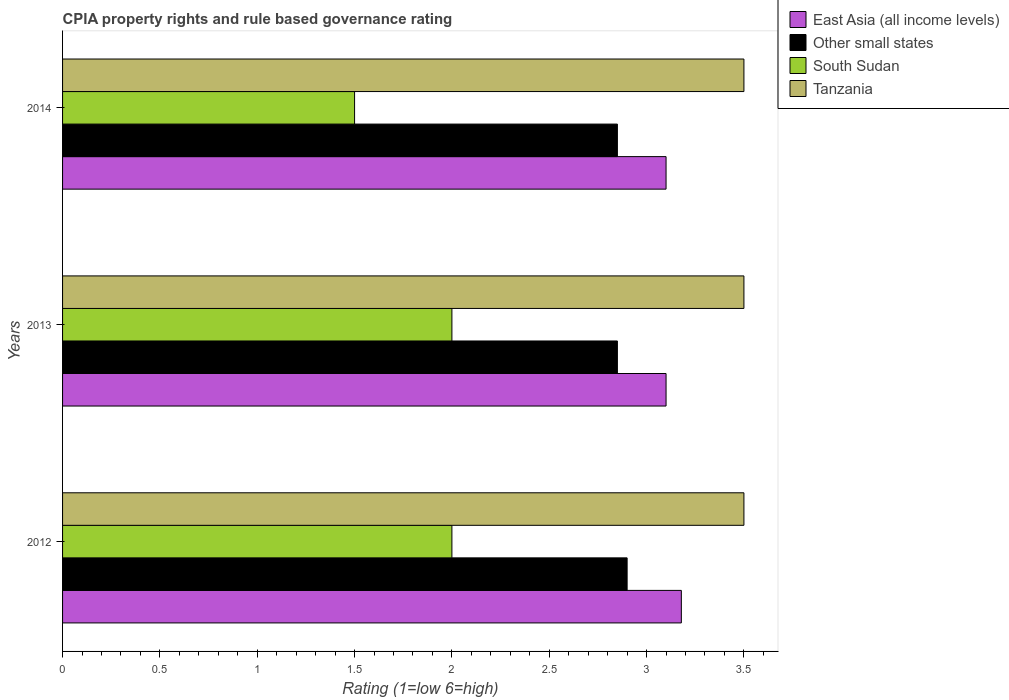How many different coloured bars are there?
Your answer should be compact. 4. In how many cases, is the number of bars for a given year not equal to the number of legend labels?
Your answer should be very brief. 0. What is the CPIA rating in East Asia (all income levels) in 2012?
Provide a short and direct response. 3.18. Across all years, what is the maximum CPIA rating in East Asia (all income levels)?
Provide a short and direct response. 3.18. Across all years, what is the minimum CPIA rating in Tanzania?
Make the answer very short. 3.5. In which year was the CPIA rating in Tanzania maximum?
Give a very brief answer. 2012. What is the total CPIA rating in Other small states in the graph?
Keep it short and to the point. 8.6. What is the difference between the CPIA rating in Other small states in 2012 and that in 2014?
Provide a succinct answer. 0.05. What is the difference between the CPIA rating in Other small states in 2014 and the CPIA rating in South Sudan in 2012?
Provide a short and direct response. 0.85. What is the average CPIA rating in Other small states per year?
Give a very brief answer. 2.87. In the year 2012, what is the difference between the CPIA rating in Other small states and CPIA rating in South Sudan?
Ensure brevity in your answer.  0.9. Is the difference between the CPIA rating in Other small states in 2013 and 2014 greater than the difference between the CPIA rating in South Sudan in 2013 and 2014?
Your answer should be compact. No. What is the difference between the highest and the second highest CPIA rating in East Asia (all income levels)?
Give a very brief answer. 0.08. In how many years, is the CPIA rating in East Asia (all income levels) greater than the average CPIA rating in East Asia (all income levels) taken over all years?
Offer a terse response. 1. Is the sum of the CPIA rating in South Sudan in 2013 and 2014 greater than the maximum CPIA rating in East Asia (all income levels) across all years?
Offer a very short reply. Yes. Is it the case that in every year, the sum of the CPIA rating in East Asia (all income levels) and CPIA rating in Other small states is greater than the sum of CPIA rating in Tanzania and CPIA rating in South Sudan?
Offer a very short reply. Yes. What does the 3rd bar from the top in 2012 represents?
Keep it short and to the point. Other small states. What does the 1st bar from the bottom in 2013 represents?
Ensure brevity in your answer.  East Asia (all income levels). Is it the case that in every year, the sum of the CPIA rating in East Asia (all income levels) and CPIA rating in Other small states is greater than the CPIA rating in Tanzania?
Ensure brevity in your answer.  Yes. How many bars are there?
Keep it short and to the point. 12. Does the graph contain grids?
Your answer should be very brief. No. How many legend labels are there?
Provide a succinct answer. 4. How are the legend labels stacked?
Provide a succinct answer. Vertical. What is the title of the graph?
Your answer should be compact. CPIA property rights and rule based governance rating. Does "Tonga" appear as one of the legend labels in the graph?
Provide a short and direct response. No. What is the label or title of the X-axis?
Give a very brief answer. Rating (1=low 6=high). What is the label or title of the Y-axis?
Offer a very short reply. Years. What is the Rating (1=low 6=high) in East Asia (all income levels) in 2012?
Your answer should be very brief. 3.18. What is the Rating (1=low 6=high) in South Sudan in 2012?
Your response must be concise. 2. What is the Rating (1=low 6=high) of Tanzania in 2012?
Offer a very short reply. 3.5. What is the Rating (1=low 6=high) in East Asia (all income levels) in 2013?
Your answer should be very brief. 3.1. What is the Rating (1=low 6=high) of Other small states in 2013?
Your answer should be compact. 2.85. What is the Rating (1=low 6=high) in Other small states in 2014?
Your response must be concise. 2.85. What is the Rating (1=low 6=high) of South Sudan in 2014?
Your answer should be very brief. 1.5. What is the Rating (1=low 6=high) of Tanzania in 2014?
Ensure brevity in your answer.  3.5. Across all years, what is the maximum Rating (1=low 6=high) of East Asia (all income levels)?
Provide a short and direct response. 3.18. Across all years, what is the maximum Rating (1=low 6=high) in Other small states?
Offer a very short reply. 2.9. Across all years, what is the minimum Rating (1=low 6=high) in East Asia (all income levels)?
Provide a succinct answer. 3.1. Across all years, what is the minimum Rating (1=low 6=high) of Other small states?
Your answer should be very brief. 2.85. What is the total Rating (1=low 6=high) of East Asia (all income levels) in the graph?
Your answer should be compact. 9.38. What is the total Rating (1=low 6=high) of Other small states in the graph?
Offer a very short reply. 8.6. What is the total Rating (1=low 6=high) in South Sudan in the graph?
Ensure brevity in your answer.  5.5. What is the difference between the Rating (1=low 6=high) in East Asia (all income levels) in 2012 and that in 2013?
Make the answer very short. 0.08. What is the difference between the Rating (1=low 6=high) in South Sudan in 2012 and that in 2013?
Offer a terse response. 0. What is the difference between the Rating (1=low 6=high) of East Asia (all income levels) in 2012 and that in 2014?
Keep it short and to the point. 0.08. What is the difference between the Rating (1=low 6=high) in Other small states in 2012 and that in 2014?
Give a very brief answer. 0.05. What is the difference between the Rating (1=low 6=high) of Tanzania in 2012 and that in 2014?
Keep it short and to the point. 0. What is the difference between the Rating (1=low 6=high) of South Sudan in 2013 and that in 2014?
Provide a succinct answer. 0.5. What is the difference between the Rating (1=low 6=high) in Tanzania in 2013 and that in 2014?
Offer a terse response. 0. What is the difference between the Rating (1=low 6=high) of East Asia (all income levels) in 2012 and the Rating (1=low 6=high) of Other small states in 2013?
Give a very brief answer. 0.33. What is the difference between the Rating (1=low 6=high) in East Asia (all income levels) in 2012 and the Rating (1=low 6=high) in South Sudan in 2013?
Your answer should be very brief. 1.18. What is the difference between the Rating (1=low 6=high) of East Asia (all income levels) in 2012 and the Rating (1=low 6=high) of Tanzania in 2013?
Give a very brief answer. -0.32. What is the difference between the Rating (1=low 6=high) in Other small states in 2012 and the Rating (1=low 6=high) in South Sudan in 2013?
Your response must be concise. 0.9. What is the difference between the Rating (1=low 6=high) of Other small states in 2012 and the Rating (1=low 6=high) of Tanzania in 2013?
Ensure brevity in your answer.  -0.6. What is the difference between the Rating (1=low 6=high) of East Asia (all income levels) in 2012 and the Rating (1=low 6=high) of Other small states in 2014?
Provide a succinct answer. 0.33. What is the difference between the Rating (1=low 6=high) in East Asia (all income levels) in 2012 and the Rating (1=low 6=high) in South Sudan in 2014?
Make the answer very short. 1.68. What is the difference between the Rating (1=low 6=high) in East Asia (all income levels) in 2012 and the Rating (1=low 6=high) in Tanzania in 2014?
Your response must be concise. -0.32. What is the difference between the Rating (1=low 6=high) in South Sudan in 2012 and the Rating (1=low 6=high) in Tanzania in 2014?
Provide a short and direct response. -1.5. What is the difference between the Rating (1=low 6=high) in Other small states in 2013 and the Rating (1=low 6=high) in South Sudan in 2014?
Your answer should be compact. 1.35. What is the difference between the Rating (1=low 6=high) of Other small states in 2013 and the Rating (1=low 6=high) of Tanzania in 2014?
Your answer should be compact. -0.65. What is the average Rating (1=low 6=high) of East Asia (all income levels) per year?
Offer a terse response. 3.13. What is the average Rating (1=low 6=high) of Other small states per year?
Provide a succinct answer. 2.87. What is the average Rating (1=low 6=high) of South Sudan per year?
Your answer should be compact. 1.83. In the year 2012, what is the difference between the Rating (1=low 6=high) in East Asia (all income levels) and Rating (1=low 6=high) in Other small states?
Your response must be concise. 0.28. In the year 2012, what is the difference between the Rating (1=low 6=high) of East Asia (all income levels) and Rating (1=low 6=high) of South Sudan?
Your answer should be compact. 1.18. In the year 2012, what is the difference between the Rating (1=low 6=high) in East Asia (all income levels) and Rating (1=low 6=high) in Tanzania?
Ensure brevity in your answer.  -0.32. In the year 2012, what is the difference between the Rating (1=low 6=high) of Other small states and Rating (1=low 6=high) of South Sudan?
Your answer should be very brief. 0.9. In the year 2012, what is the difference between the Rating (1=low 6=high) of Other small states and Rating (1=low 6=high) of Tanzania?
Offer a very short reply. -0.6. In the year 2013, what is the difference between the Rating (1=low 6=high) of East Asia (all income levels) and Rating (1=low 6=high) of Other small states?
Your response must be concise. 0.25. In the year 2013, what is the difference between the Rating (1=low 6=high) of East Asia (all income levels) and Rating (1=low 6=high) of Tanzania?
Ensure brevity in your answer.  -0.4. In the year 2013, what is the difference between the Rating (1=low 6=high) of Other small states and Rating (1=low 6=high) of Tanzania?
Provide a succinct answer. -0.65. In the year 2014, what is the difference between the Rating (1=low 6=high) of East Asia (all income levels) and Rating (1=low 6=high) of Tanzania?
Ensure brevity in your answer.  -0.4. In the year 2014, what is the difference between the Rating (1=low 6=high) of Other small states and Rating (1=low 6=high) of South Sudan?
Keep it short and to the point. 1.35. In the year 2014, what is the difference between the Rating (1=low 6=high) of Other small states and Rating (1=low 6=high) of Tanzania?
Make the answer very short. -0.65. In the year 2014, what is the difference between the Rating (1=low 6=high) in South Sudan and Rating (1=low 6=high) in Tanzania?
Make the answer very short. -2. What is the ratio of the Rating (1=low 6=high) of East Asia (all income levels) in 2012 to that in 2013?
Provide a succinct answer. 1.03. What is the ratio of the Rating (1=low 6=high) in Other small states in 2012 to that in 2013?
Provide a short and direct response. 1.02. What is the ratio of the Rating (1=low 6=high) of East Asia (all income levels) in 2012 to that in 2014?
Keep it short and to the point. 1.03. What is the ratio of the Rating (1=low 6=high) in Other small states in 2012 to that in 2014?
Provide a short and direct response. 1.02. What is the ratio of the Rating (1=low 6=high) in East Asia (all income levels) in 2013 to that in 2014?
Provide a succinct answer. 1. What is the difference between the highest and the second highest Rating (1=low 6=high) of East Asia (all income levels)?
Your answer should be very brief. 0.08. What is the difference between the highest and the second highest Rating (1=low 6=high) of Other small states?
Provide a short and direct response. 0.05. What is the difference between the highest and the second highest Rating (1=low 6=high) in South Sudan?
Provide a short and direct response. 0. What is the difference between the highest and the second highest Rating (1=low 6=high) of Tanzania?
Give a very brief answer. 0. What is the difference between the highest and the lowest Rating (1=low 6=high) in East Asia (all income levels)?
Provide a succinct answer. 0.08. What is the difference between the highest and the lowest Rating (1=low 6=high) of South Sudan?
Make the answer very short. 0.5. 